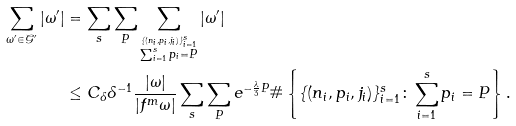<formula> <loc_0><loc_0><loc_500><loc_500>\sum _ { \omega ^ { \prime } \in \mathcal { G } ^ { \prime } } | \omega ^ { \prime } | & = \sum _ { s } \sum _ { P } \sum _ { \stackrel { \{ ( n _ { i } , p _ { i } , j _ { i } ) \} _ { i = 1 } ^ { s } } { \sum _ { i = 1 } ^ { s } p _ { i } = P } } | \omega ^ { \prime } | \\ & \leq C _ { \delta } \delta ^ { - 1 } \frac { | \omega | } { | f ^ { m } \omega | } \sum _ { s } \sum _ { P } e ^ { - \frac { \lambda } { 3 } P } \# \left \{ \{ ( n _ { i } , p _ { i } , j _ { i } ) \} _ { i = 1 } ^ { s } \colon \sum _ { i = 1 } ^ { s } p _ { i } = P \right \} .</formula> 